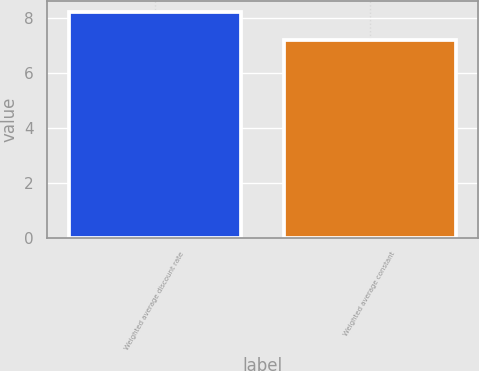Convert chart to OTSL. <chart><loc_0><loc_0><loc_500><loc_500><bar_chart><fcel>Weighted average discount rate<fcel>Weighted average constant<nl><fcel>8.2<fcel>7.2<nl></chart> 